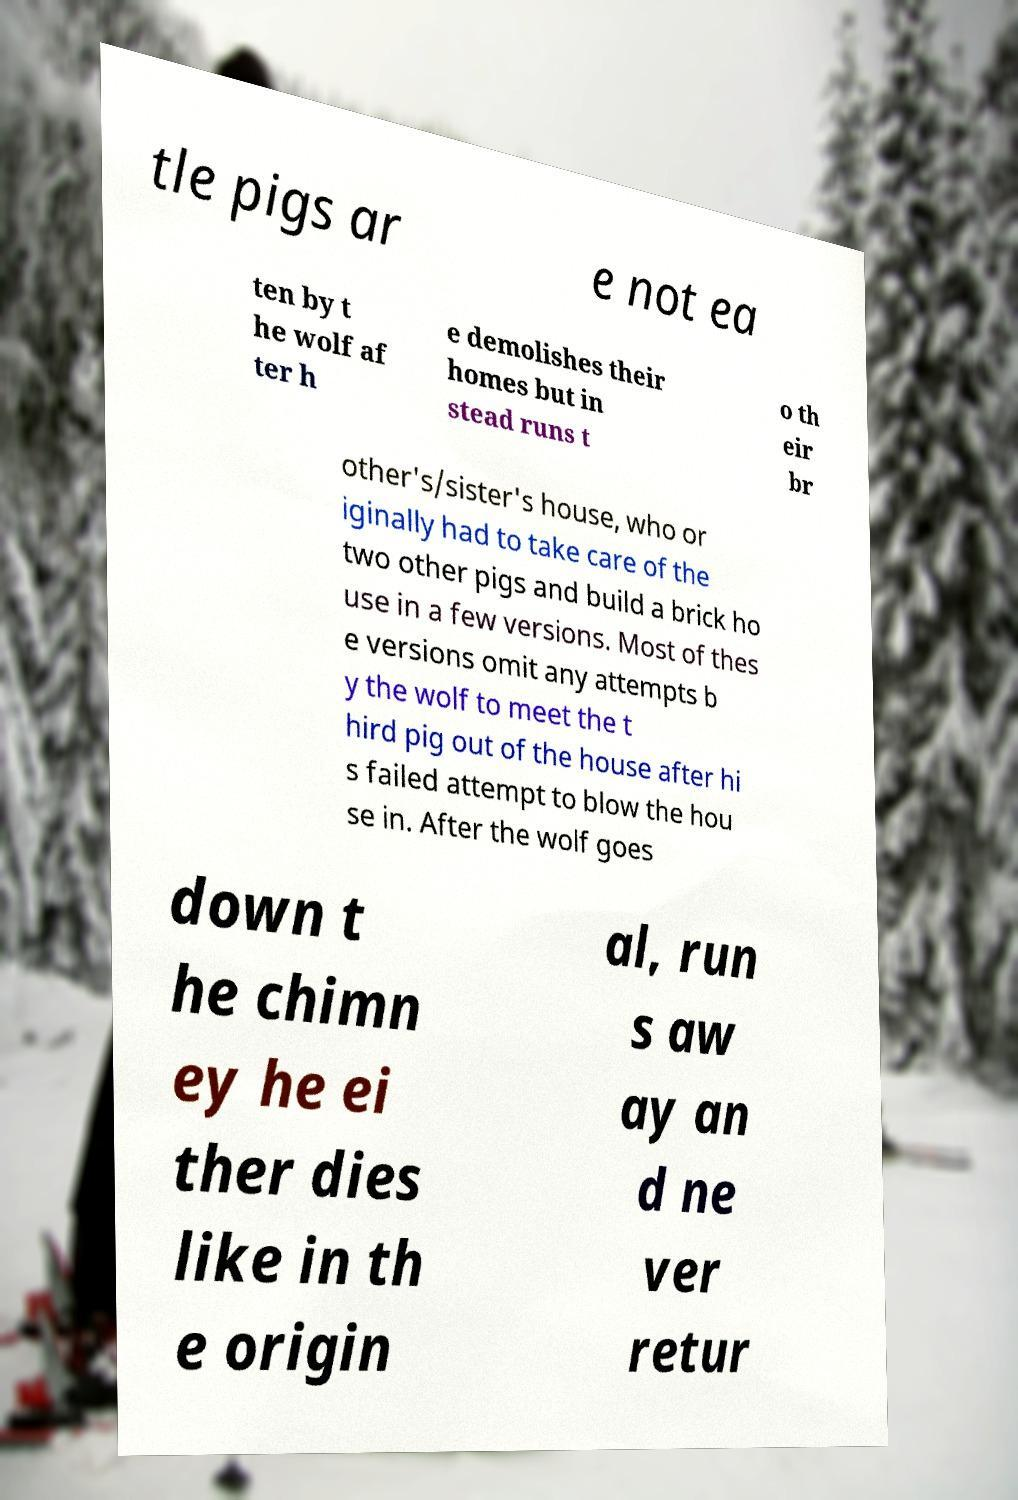What messages or text are displayed in this image? I need them in a readable, typed format. tle pigs ar e not ea ten by t he wolf af ter h e demolishes their homes but in stead runs t o th eir br other's/sister's house, who or iginally had to take care of the two other pigs and build a brick ho use in a few versions. Most of thes e versions omit any attempts b y the wolf to meet the t hird pig out of the house after hi s failed attempt to blow the hou se in. After the wolf goes down t he chimn ey he ei ther dies like in th e origin al, run s aw ay an d ne ver retur 